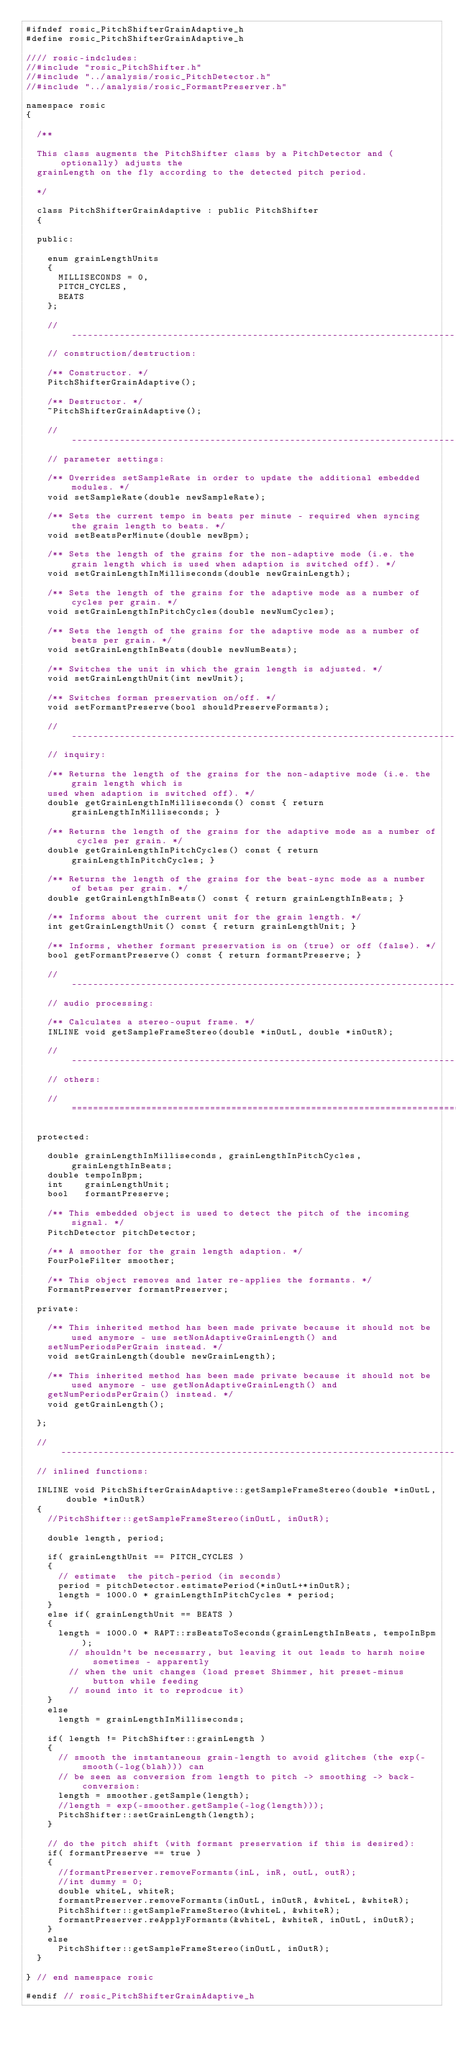Convert code to text. <code><loc_0><loc_0><loc_500><loc_500><_C_>#ifndef rosic_PitchShifterGrainAdaptive_h
#define rosic_PitchShifterGrainAdaptive_h

//// rosic-indcludes:
//#include "rosic_PitchShifter.h"
//#include "../analysis/rosic_PitchDetector.h"
//#include "../analysis/rosic_FormantPreserver.h"

namespace rosic
{

  /**

  This class augments the PitchShifter class by a PitchDetector and (optionally) adjusts the
  grainLength on the fly according to the detected pitch period.

  */

  class PitchShifterGrainAdaptive : public PitchShifter
  {

  public:

    enum grainLengthUnits
    {
      MILLISECONDS = 0,
      PITCH_CYCLES,
      BEATS
    };

    //-------------------------------------------------------------------------------------------------------------------------------------
    // construction/destruction:

    /** Constructor. */
    PitchShifterGrainAdaptive();

    /** Destructor. */
    ~PitchShifterGrainAdaptive();

    //-------------------------------------------------------------------------------------------------------------------------------------
    // parameter settings:

    /** Overrides setSampleRate in order to update the additional embedded modules. */
    void setSampleRate(double newSampleRate);

    /** Sets the current tempo in beats per minute - required when syncing the grain length to beats. */
    void setBeatsPerMinute(double newBpm);

    /** Sets the length of the grains for the non-adaptive mode (i.e. the grain length which is used when adaption is switched off). */
    void setGrainLengthInMilliseconds(double newGrainLength);

    /** Sets the length of the grains for the adaptive mode as a number of cycles per grain. */
    void setGrainLengthInPitchCycles(double newNumCycles);

    /** Sets the length of the grains for the adaptive mode as a number of beats per grain. */
    void setGrainLengthInBeats(double newNumBeats);

    /** Switches the unit in which the grain length is adjusted. */
    void setGrainLengthUnit(int newUnit);

    /** Switches forman preservation on/off. */
    void setFormantPreserve(bool shouldPreserveFormants);

    //-------------------------------------------------------------------------------------------------------------------------------------
    // inquiry:

    /** Returns the length of the grains for the non-adaptive mode (i.e. the grain length which is
    used when adaption is switched off). */
    double getGrainLengthInMilliseconds() const { return grainLengthInMilliseconds; }

    /** Returns the length of the grains for the adaptive mode as a number of cycles per grain. */
    double getGrainLengthInPitchCycles() const { return grainLengthInPitchCycles; }

    /** Returns the length of the grains for the beat-sync mode as a number of betas per grain. */
    double getGrainLengthInBeats() const { return grainLengthInBeats; }

    /** Informs about the current unit for the grain length. */
    int getGrainLengthUnit() const { return grainLengthUnit; }

    /** Informs, whether formant preservation is on (true) or off (false). */
    bool getFormantPreserve() const { return formantPreserve; }

    //-------------------------------------------------------------------------------------------------------------------------------------
    // audio processing:

    /** Calculates a stereo-ouput frame. */
    INLINE void getSampleFrameStereo(double *inOutL, double *inOutR);

    //-------------------------------------------------------------------------------------------------------------------------------------
    // others:

    //=====================================================================================================================================

  protected:

    double grainLengthInMilliseconds, grainLengthInPitchCycles, grainLengthInBeats;
    double tempoInBpm;
    int    grainLengthUnit;
    bool   formantPreserve;

    /** This embedded object is used to detect the pitch of the incoming signal. */
    PitchDetector pitchDetector;

    /** A smoother for the grain length adaption. */
    FourPoleFilter smoother;

    /** This object removes and later re-applies the formants. */
    FormantPreserver formantPreserver;

  private:

    /** This inherited method has been made private because it should not be used anymore - use setNonAdaptiveGrainLength() and 
    setNumPeriodsPerGrain instead. */
    void setGrainLength(double newGrainLength);

    /** This inherited method has been made private because it should not be used anymore - use getNonAdaptiveGrainLength() and 
    getNumPeriodsPerGrain() instead. */
    void getGrainLength();

  };

  //---------------------------------------------------------------------------------------------------------------------------------------
  // inlined functions: 

  INLINE void PitchShifterGrainAdaptive::getSampleFrameStereo(double *inOutL, double *inOutR)
  {
    //PitchShifter::getSampleFrameStereo(inOutL, inOutR);

    double length, period;

    if( grainLengthUnit == PITCH_CYCLES )
    {
      // estimate  the pitch-period (in seconds)
      period = pitchDetector.estimatePeriod(*inOutL+*inOutR);
      length = 1000.0 * grainLengthInPitchCycles * period;
    }
    else if( grainLengthUnit == BEATS )
    {
      length = 1000.0 * RAPT::rsBeatsToSeconds(grainLengthInBeats, tempoInBpm);
        // shouldn't be necessarry, but leaving it out leads to harsh noise sometimes - apparently
        // when the unit changes (load preset Shimmer, hit preset-minus button while feeding
        // sound into it to reprodcue it)
    }
    else
      length = grainLengthInMilliseconds;

    if( length != PitchShifter::grainLength )
    {
      // smooth the instantaneous grain-length to avoid glitches (the exp(-smooth(-log(blah))) can
      // be seen as conversion from length to pitch -> smoothing -> back-conversion:
      length = smoother.getSample(length);
      //length = exp(-smoother.getSample(-log(length)));
      PitchShifter::setGrainLength(length);
    }

    // do the pitch shift (with formant preservation if this is desired):
    if( formantPreserve == true )
    {
      //formantPreserver.removeFormants(inL, inR, outL, outR);
      //int dummy = 0;
      double whiteL, whiteR;
      formantPreserver.removeFormants(inOutL, inOutR, &whiteL, &whiteR);
      PitchShifter::getSampleFrameStereo(&whiteL, &whiteR);
      formantPreserver.reApplyFormants(&whiteL, &whiteR, inOutL, inOutR);
    }
    else
      PitchShifter::getSampleFrameStereo(inOutL, inOutR);
  }

} // end namespace rosic

#endif // rosic_PitchShifterGrainAdaptive_h
</code> 